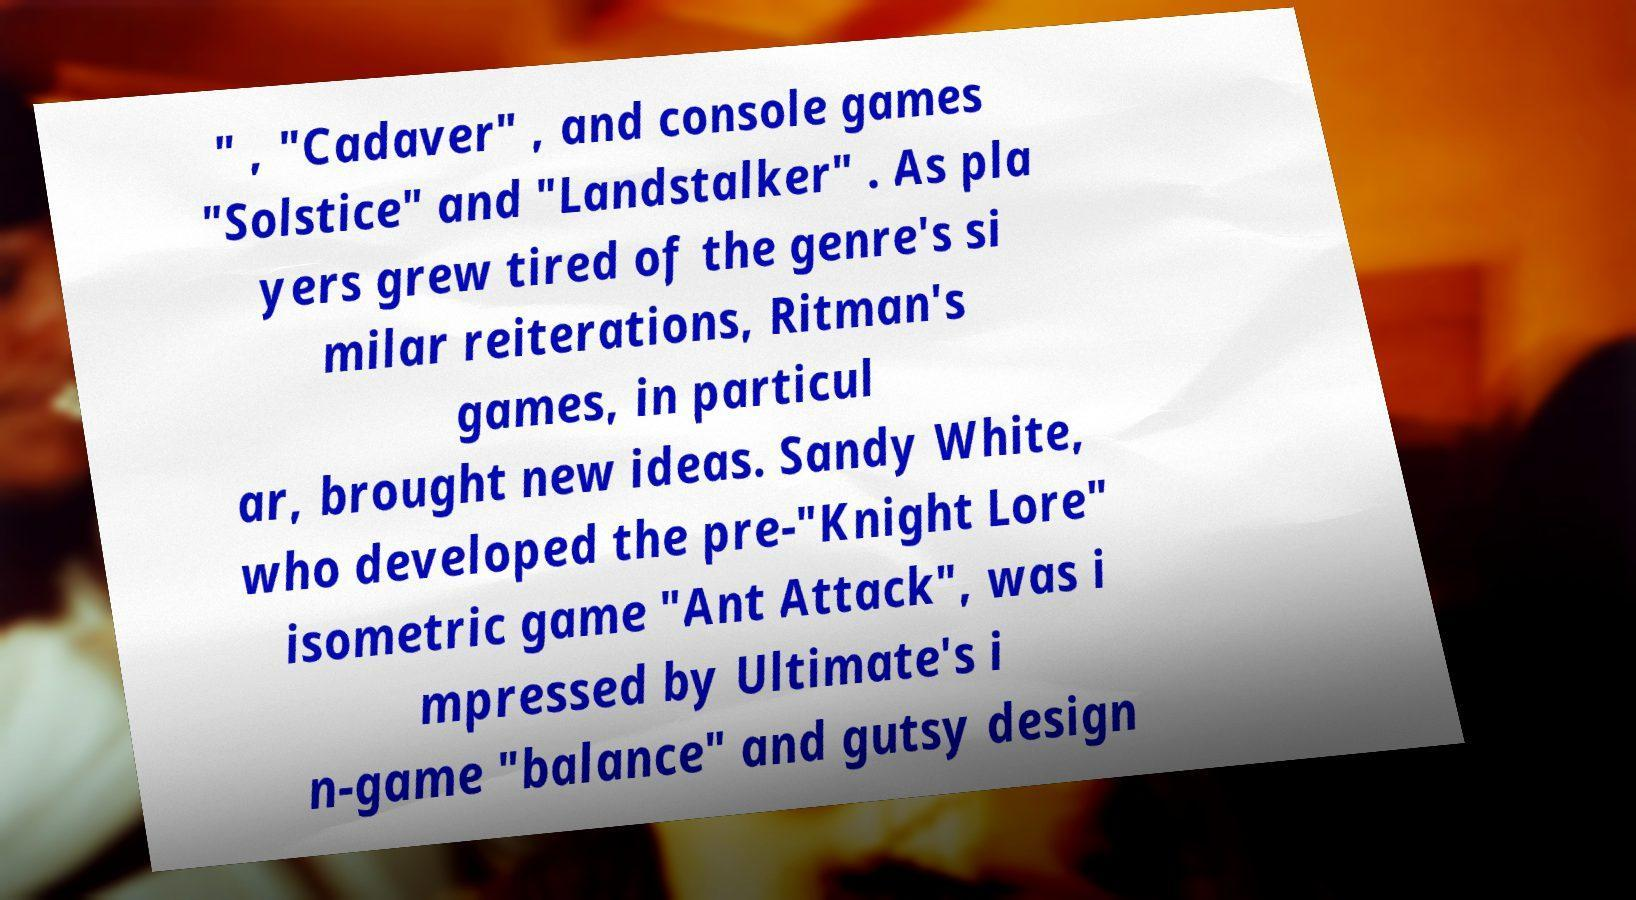Could you assist in decoding the text presented in this image and type it out clearly? " , "Cadaver" , and console games "Solstice" and "Landstalker" . As pla yers grew tired of the genre's si milar reiterations, Ritman's games, in particul ar, brought new ideas. Sandy White, who developed the pre-"Knight Lore" isometric game "Ant Attack", was i mpressed by Ultimate's i n-game "balance" and gutsy design 